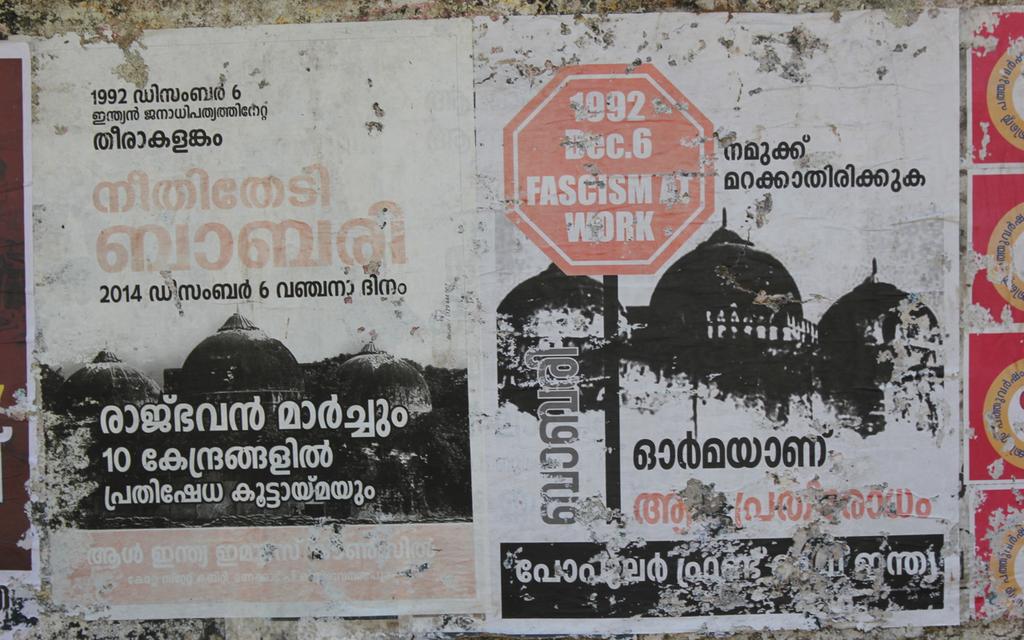What does the red stop sign say?
Offer a terse response. 1992 dec 6 fascism at work. What year is on the sign?
Your response must be concise. 1992. 